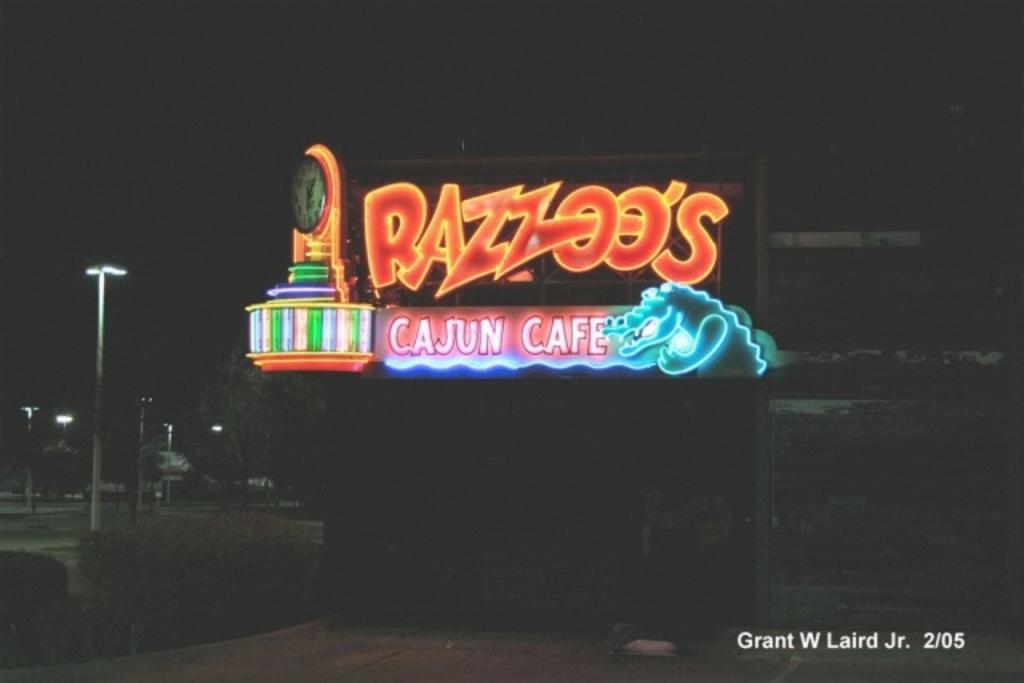<image>
Render a clear and concise summary of the photo. the word cafe is on the sign that is lit up 